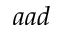Convert formula to latex. <formula><loc_0><loc_0><loc_500><loc_500>a a d</formula> 